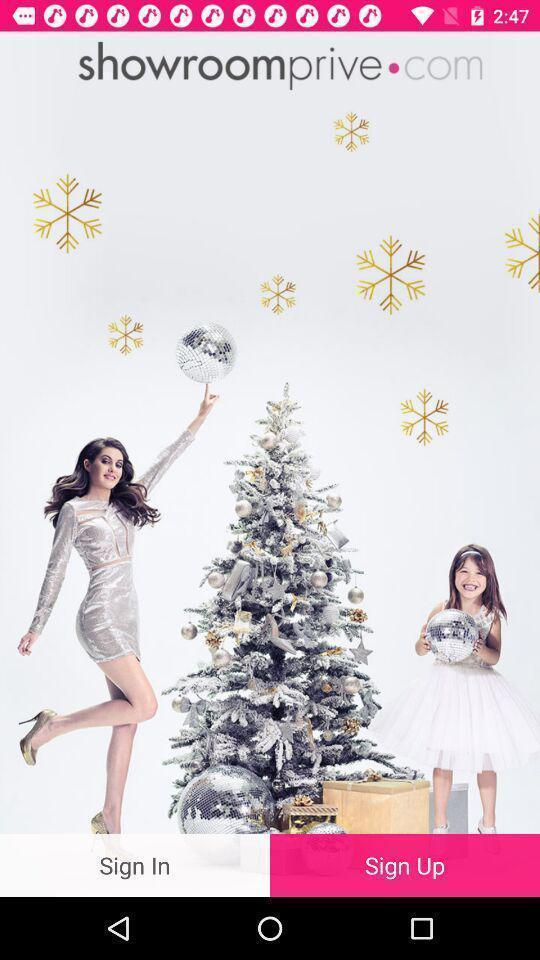What is the overall content of this screenshot? Sign in page of a shopping app. 